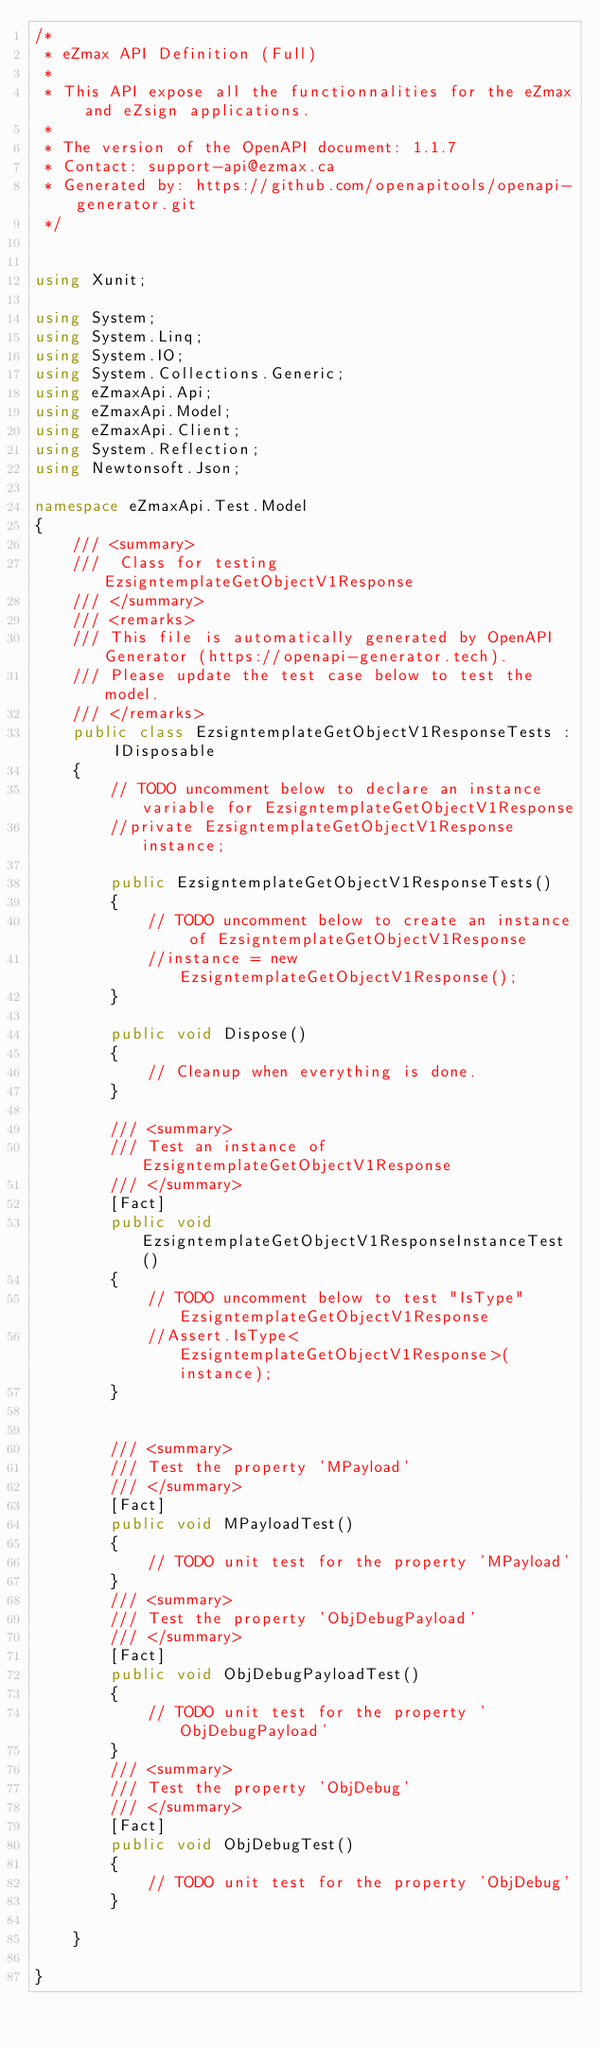<code> <loc_0><loc_0><loc_500><loc_500><_C#_>/*
 * eZmax API Definition (Full)
 *
 * This API expose all the functionnalities for the eZmax and eZsign applications.
 *
 * The version of the OpenAPI document: 1.1.7
 * Contact: support-api@ezmax.ca
 * Generated by: https://github.com/openapitools/openapi-generator.git
 */


using Xunit;

using System;
using System.Linq;
using System.IO;
using System.Collections.Generic;
using eZmaxApi.Api;
using eZmaxApi.Model;
using eZmaxApi.Client;
using System.Reflection;
using Newtonsoft.Json;

namespace eZmaxApi.Test.Model
{
    /// <summary>
    ///  Class for testing EzsigntemplateGetObjectV1Response
    /// </summary>
    /// <remarks>
    /// This file is automatically generated by OpenAPI Generator (https://openapi-generator.tech).
    /// Please update the test case below to test the model.
    /// </remarks>
    public class EzsigntemplateGetObjectV1ResponseTests : IDisposable
    {
        // TODO uncomment below to declare an instance variable for EzsigntemplateGetObjectV1Response
        //private EzsigntemplateGetObjectV1Response instance;

        public EzsigntemplateGetObjectV1ResponseTests()
        {
            // TODO uncomment below to create an instance of EzsigntemplateGetObjectV1Response
            //instance = new EzsigntemplateGetObjectV1Response();
        }

        public void Dispose()
        {
            // Cleanup when everything is done.
        }

        /// <summary>
        /// Test an instance of EzsigntemplateGetObjectV1Response
        /// </summary>
        [Fact]
        public void EzsigntemplateGetObjectV1ResponseInstanceTest()
        {
            // TODO uncomment below to test "IsType" EzsigntemplateGetObjectV1Response
            //Assert.IsType<EzsigntemplateGetObjectV1Response>(instance);
        }


        /// <summary>
        /// Test the property 'MPayload'
        /// </summary>
        [Fact]
        public void MPayloadTest()
        {
            // TODO unit test for the property 'MPayload'
        }
        /// <summary>
        /// Test the property 'ObjDebugPayload'
        /// </summary>
        [Fact]
        public void ObjDebugPayloadTest()
        {
            // TODO unit test for the property 'ObjDebugPayload'
        }
        /// <summary>
        /// Test the property 'ObjDebug'
        /// </summary>
        [Fact]
        public void ObjDebugTest()
        {
            // TODO unit test for the property 'ObjDebug'
        }

    }

}
</code> 